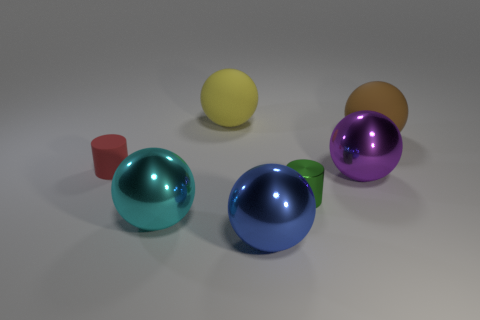Subtract all big cyan balls. How many balls are left? 4 Subtract 1 cylinders. How many cylinders are left? 1 Subtract all red cylinders. How many cylinders are left? 1 Add 2 small rubber objects. How many objects exist? 9 Subtract all balls. How many objects are left? 2 Subtract all blue blocks. How many red spheres are left? 0 Subtract all cyan cylinders. Subtract all purple balls. How many cylinders are left? 2 Add 3 big yellow rubber balls. How many big yellow rubber balls are left? 4 Add 4 blue things. How many blue things exist? 5 Subtract 0 gray blocks. How many objects are left? 7 